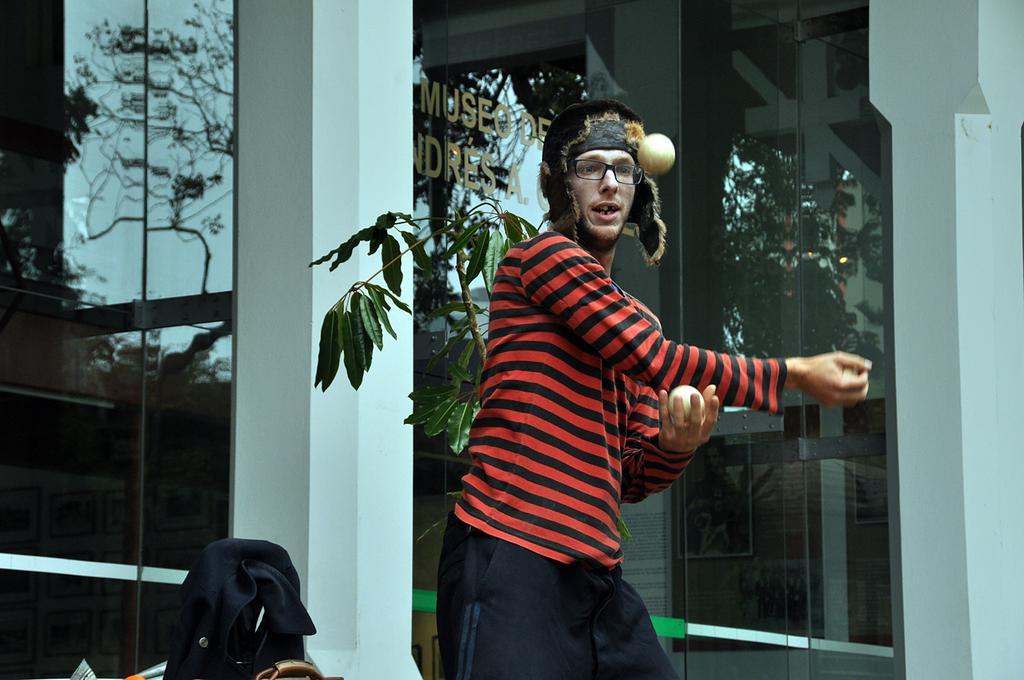How would you summarize this image in a sentence or two? In this picture I can see a man standing and doing juggling with the balls, there are some objects, and in the background there is a reflection of trees and the sky on the transparent glass. 